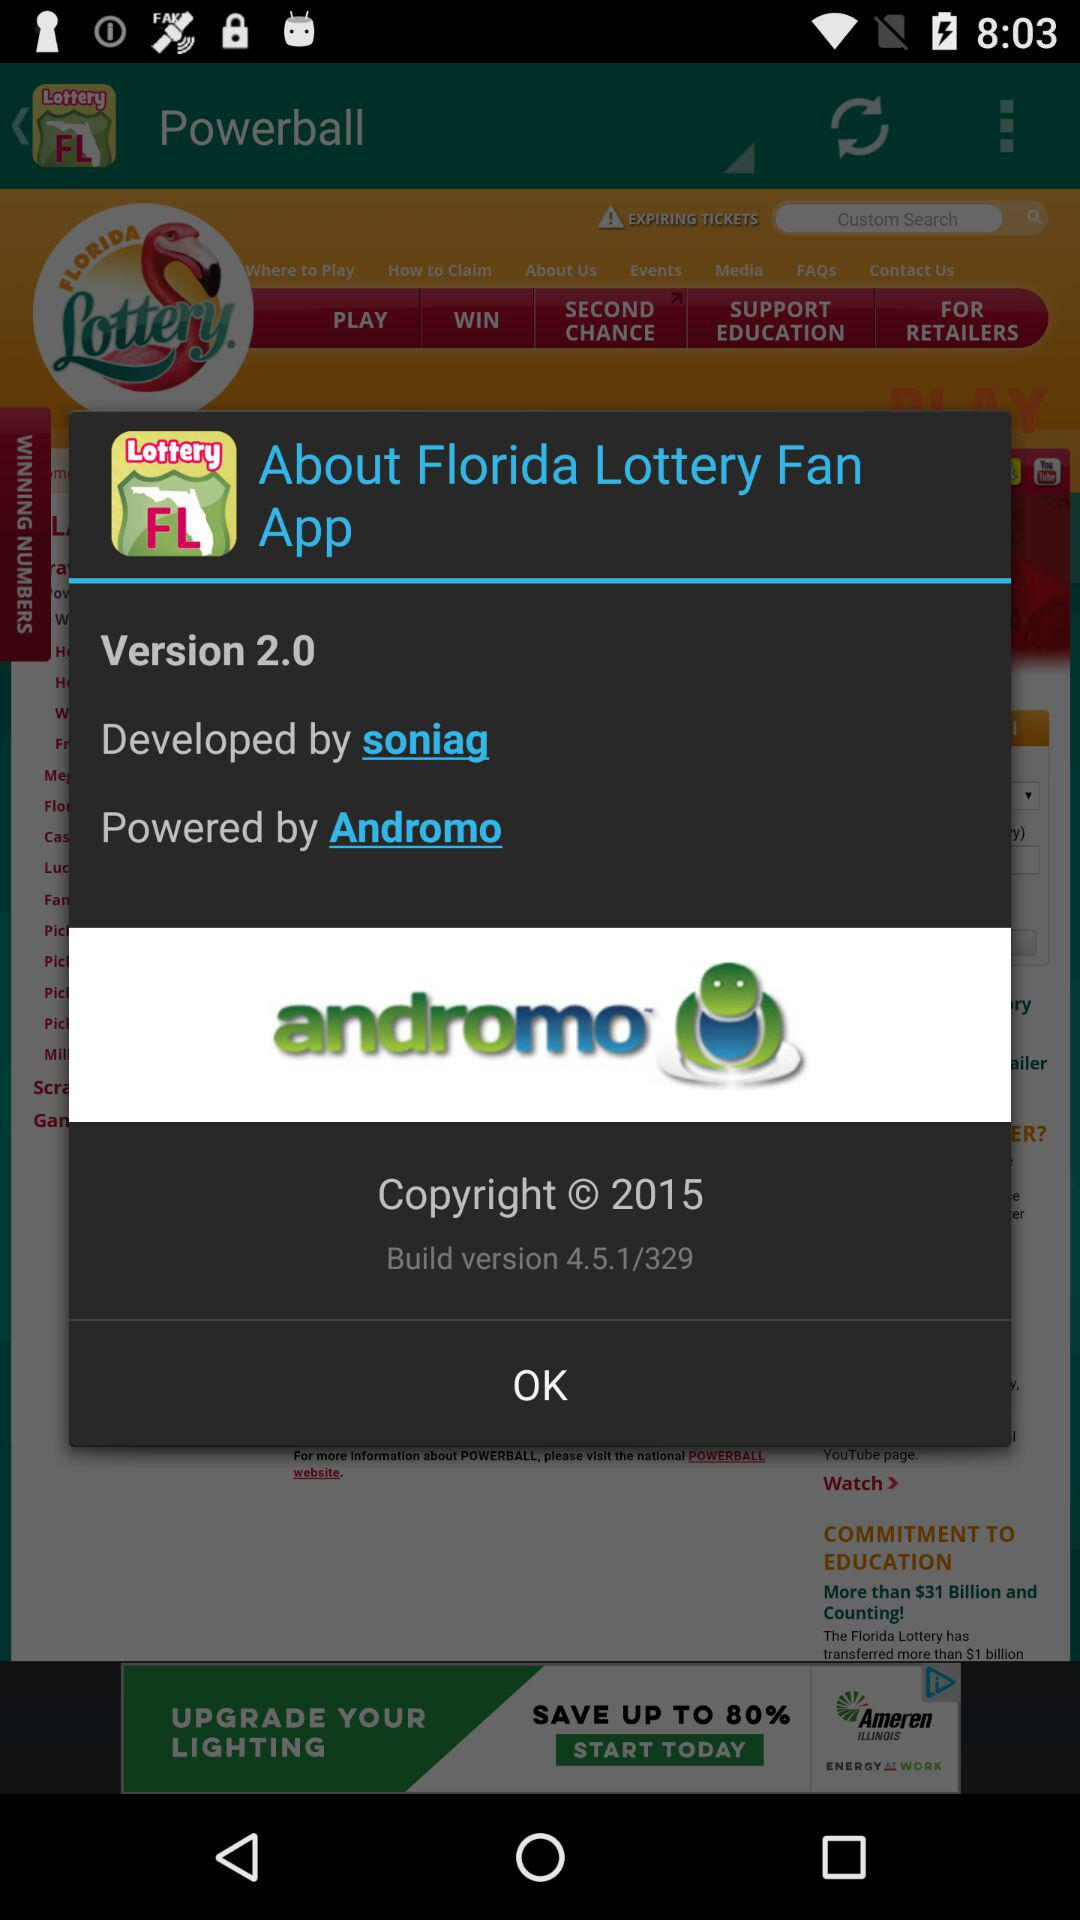What is the build version number? The build version number is 4.5.1/329. 